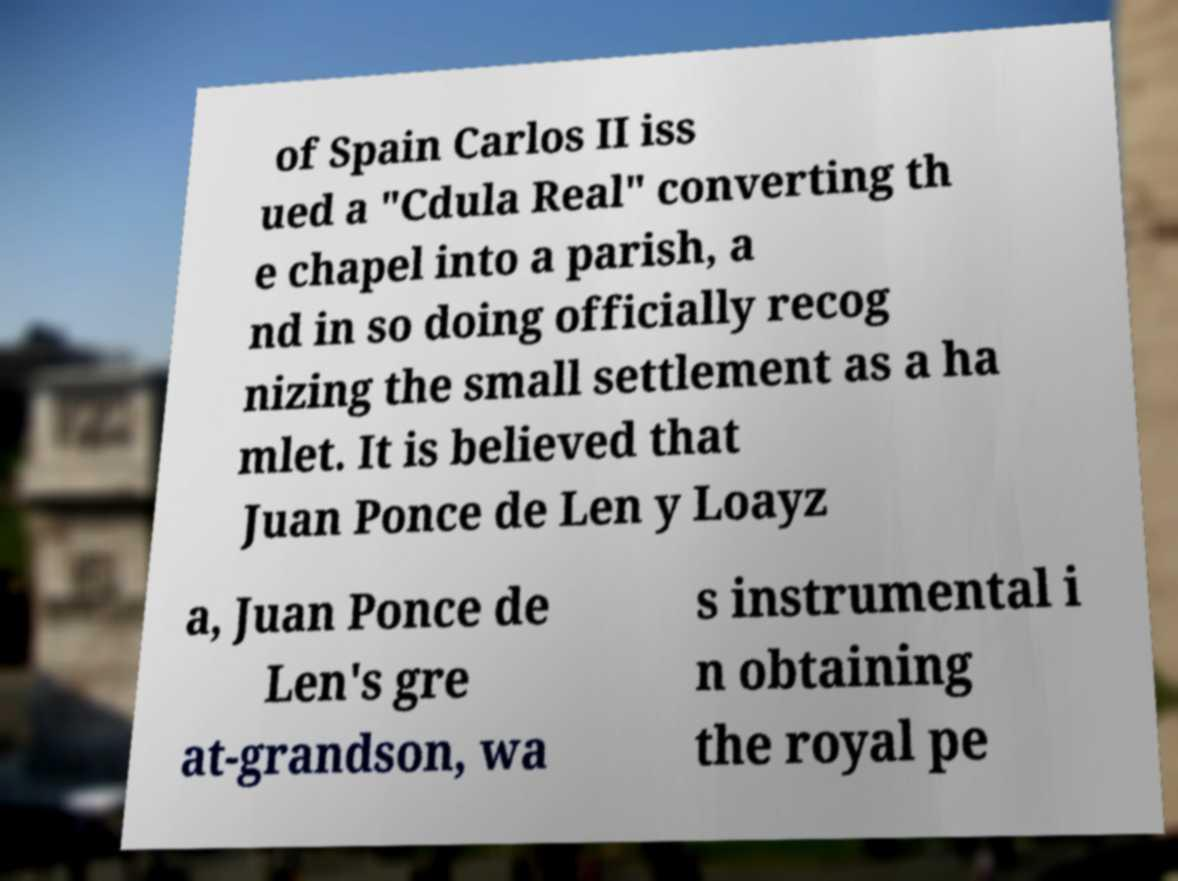Could you extract and type out the text from this image? of Spain Carlos II iss ued a "Cdula Real" converting th e chapel into a parish, a nd in so doing officially recog nizing the small settlement as a ha mlet. It is believed that Juan Ponce de Len y Loayz a, Juan Ponce de Len's gre at-grandson, wa s instrumental i n obtaining the royal pe 